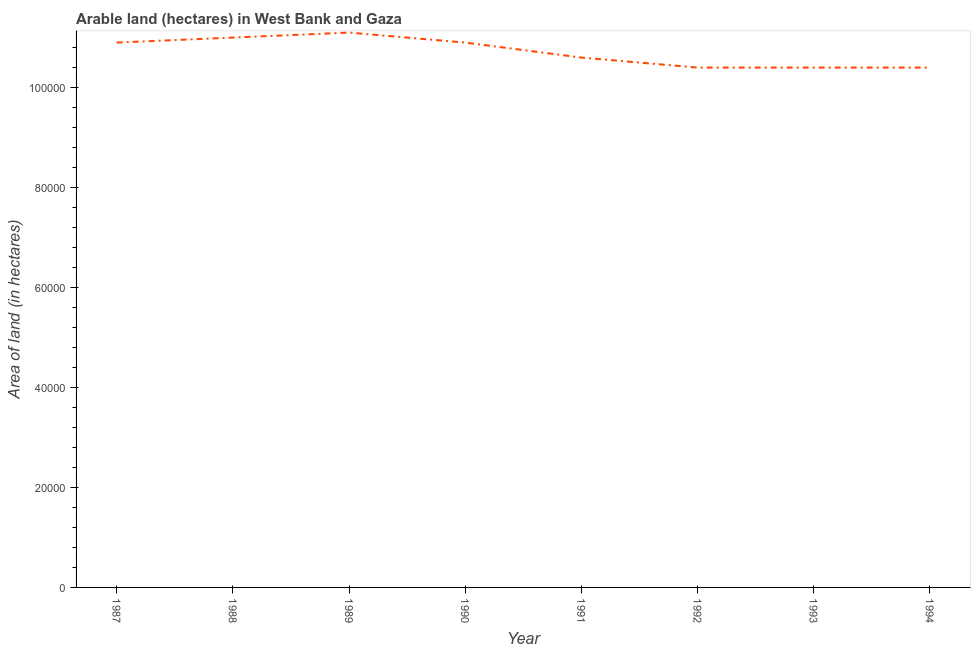What is the area of land in 1992?
Offer a very short reply. 1.04e+05. Across all years, what is the maximum area of land?
Make the answer very short. 1.11e+05. Across all years, what is the minimum area of land?
Offer a very short reply. 1.04e+05. In which year was the area of land maximum?
Offer a terse response. 1989. What is the sum of the area of land?
Make the answer very short. 8.57e+05. What is the difference between the area of land in 1989 and 1992?
Your answer should be compact. 7000. What is the average area of land per year?
Provide a succinct answer. 1.07e+05. What is the median area of land?
Offer a terse response. 1.08e+05. In how many years, is the area of land greater than 72000 hectares?
Ensure brevity in your answer.  8. What is the ratio of the area of land in 1990 to that in 1993?
Offer a terse response. 1.05. Is the area of land in 1987 less than that in 1988?
Your response must be concise. Yes. Is the difference between the area of land in 1988 and 1989 greater than the difference between any two years?
Your answer should be very brief. No. Is the sum of the area of land in 1992 and 1994 greater than the maximum area of land across all years?
Your response must be concise. Yes. What is the difference between the highest and the lowest area of land?
Your response must be concise. 7000. Does the area of land monotonically increase over the years?
Provide a short and direct response. No. What is the difference between two consecutive major ticks on the Y-axis?
Make the answer very short. 2.00e+04. Are the values on the major ticks of Y-axis written in scientific E-notation?
Make the answer very short. No. Does the graph contain any zero values?
Offer a terse response. No. What is the title of the graph?
Provide a short and direct response. Arable land (hectares) in West Bank and Gaza. What is the label or title of the X-axis?
Provide a succinct answer. Year. What is the label or title of the Y-axis?
Your answer should be compact. Area of land (in hectares). What is the Area of land (in hectares) in 1987?
Provide a succinct answer. 1.09e+05. What is the Area of land (in hectares) of 1989?
Your answer should be compact. 1.11e+05. What is the Area of land (in hectares) in 1990?
Give a very brief answer. 1.09e+05. What is the Area of land (in hectares) in 1991?
Provide a succinct answer. 1.06e+05. What is the Area of land (in hectares) of 1992?
Provide a short and direct response. 1.04e+05. What is the Area of land (in hectares) in 1993?
Make the answer very short. 1.04e+05. What is the Area of land (in hectares) in 1994?
Your answer should be very brief. 1.04e+05. What is the difference between the Area of land (in hectares) in 1987 and 1988?
Provide a short and direct response. -1000. What is the difference between the Area of land (in hectares) in 1987 and 1989?
Your answer should be very brief. -2000. What is the difference between the Area of land (in hectares) in 1987 and 1990?
Offer a terse response. 0. What is the difference between the Area of land (in hectares) in 1987 and 1991?
Provide a succinct answer. 3000. What is the difference between the Area of land (in hectares) in 1987 and 1992?
Offer a very short reply. 5000. What is the difference between the Area of land (in hectares) in 1987 and 1993?
Ensure brevity in your answer.  5000. What is the difference between the Area of land (in hectares) in 1988 and 1989?
Provide a succinct answer. -1000. What is the difference between the Area of land (in hectares) in 1988 and 1991?
Make the answer very short. 4000. What is the difference between the Area of land (in hectares) in 1988 and 1992?
Your answer should be very brief. 6000. What is the difference between the Area of land (in hectares) in 1988 and 1993?
Your answer should be compact. 6000. What is the difference between the Area of land (in hectares) in 1988 and 1994?
Provide a succinct answer. 6000. What is the difference between the Area of land (in hectares) in 1989 and 1992?
Give a very brief answer. 7000. What is the difference between the Area of land (in hectares) in 1989 and 1993?
Give a very brief answer. 7000. What is the difference between the Area of land (in hectares) in 1989 and 1994?
Ensure brevity in your answer.  7000. What is the difference between the Area of land (in hectares) in 1990 and 1991?
Your answer should be very brief. 3000. What is the difference between the Area of land (in hectares) in 1991 and 1992?
Your answer should be compact. 2000. What is the difference between the Area of land (in hectares) in 1992 and 1993?
Keep it short and to the point. 0. What is the difference between the Area of land (in hectares) in 1992 and 1994?
Offer a terse response. 0. What is the ratio of the Area of land (in hectares) in 1987 to that in 1988?
Ensure brevity in your answer.  0.99. What is the ratio of the Area of land (in hectares) in 1987 to that in 1990?
Your answer should be compact. 1. What is the ratio of the Area of land (in hectares) in 1987 to that in 1991?
Your response must be concise. 1.03. What is the ratio of the Area of land (in hectares) in 1987 to that in 1992?
Offer a terse response. 1.05. What is the ratio of the Area of land (in hectares) in 1987 to that in 1993?
Provide a short and direct response. 1.05. What is the ratio of the Area of land (in hectares) in 1987 to that in 1994?
Make the answer very short. 1.05. What is the ratio of the Area of land (in hectares) in 1988 to that in 1989?
Ensure brevity in your answer.  0.99. What is the ratio of the Area of land (in hectares) in 1988 to that in 1991?
Make the answer very short. 1.04. What is the ratio of the Area of land (in hectares) in 1988 to that in 1992?
Provide a succinct answer. 1.06. What is the ratio of the Area of land (in hectares) in 1988 to that in 1993?
Provide a succinct answer. 1.06. What is the ratio of the Area of land (in hectares) in 1988 to that in 1994?
Your answer should be compact. 1.06. What is the ratio of the Area of land (in hectares) in 1989 to that in 1990?
Your response must be concise. 1.02. What is the ratio of the Area of land (in hectares) in 1989 to that in 1991?
Offer a terse response. 1.05. What is the ratio of the Area of land (in hectares) in 1989 to that in 1992?
Offer a terse response. 1.07. What is the ratio of the Area of land (in hectares) in 1989 to that in 1993?
Provide a succinct answer. 1.07. What is the ratio of the Area of land (in hectares) in 1989 to that in 1994?
Give a very brief answer. 1.07. What is the ratio of the Area of land (in hectares) in 1990 to that in 1991?
Offer a very short reply. 1.03. What is the ratio of the Area of land (in hectares) in 1990 to that in 1992?
Give a very brief answer. 1.05. What is the ratio of the Area of land (in hectares) in 1990 to that in 1993?
Provide a succinct answer. 1.05. What is the ratio of the Area of land (in hectares) in 1990 to that in 1994?
Keep it short and to the point. 1.05. What is the ratio of the Area of land (in hectares) in 1991 to that in 1992?
Your response must be concise. 1.02. What is the ratio of the Area of land (in hectares) in 1991 to that in 1993?
Provide a short and direct response. 1.02. What is the ratio of the Area of land (in hectares) in 1992 to that in 1993?
Provide a short and direct response. 1. What is the ratio of the Area of land (in hectares) in 1992 to that in 1994?
Your answer should be very brief. 1. What is the ratio of the Area of land (in hectares) in 1993 to that in 1994?
Make the answer very short. 1. 